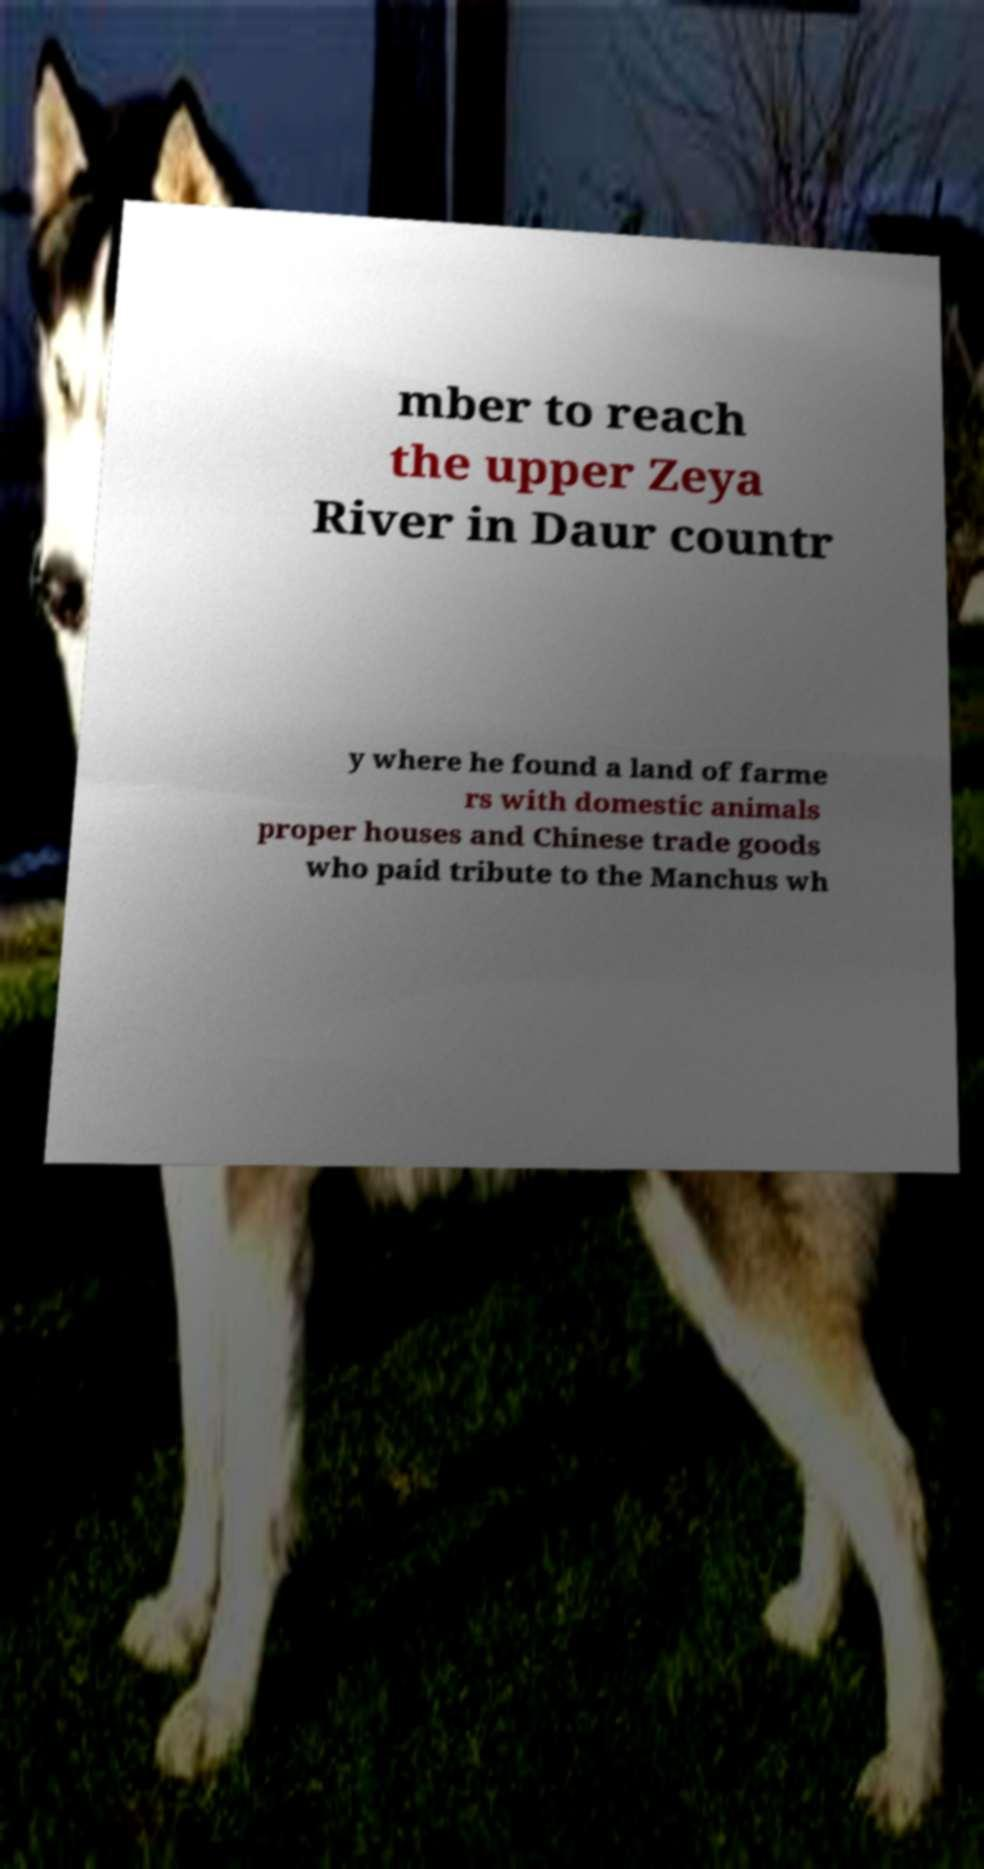For documentation purposes, I need the text within this image transcribed. Could you provide that? mber to reach the upper Zeya River in Daur countr y where he found a land of farme rs with domestic animals proper houses and Chinese trade goods who paid tribute to the Manchus wh 